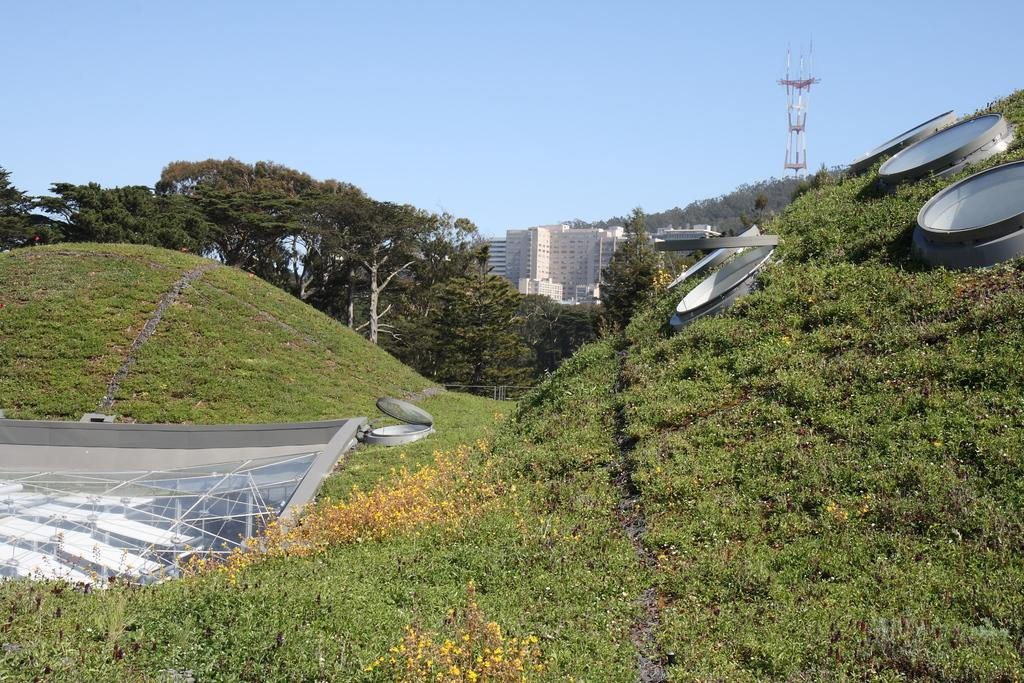What type of vegetation is present in the image? There is grass in the image. What other natural elements can be seen in the image? There are trees in the image. What man-made structures are visible in the image? There are buildings and a tower in the image. What else can be seen in the image besides the vegetation, structures, and tower? There are some unspecified objects in the image. What is visible in the background of the image? The sky is visible in the background of the image. Can you see any poisonous fish in the image? There are no fish, poisonous or otherwise, present in the image. What is the end result of the tower in the image? The image does not provide information about the purpose or end result of the tower. 